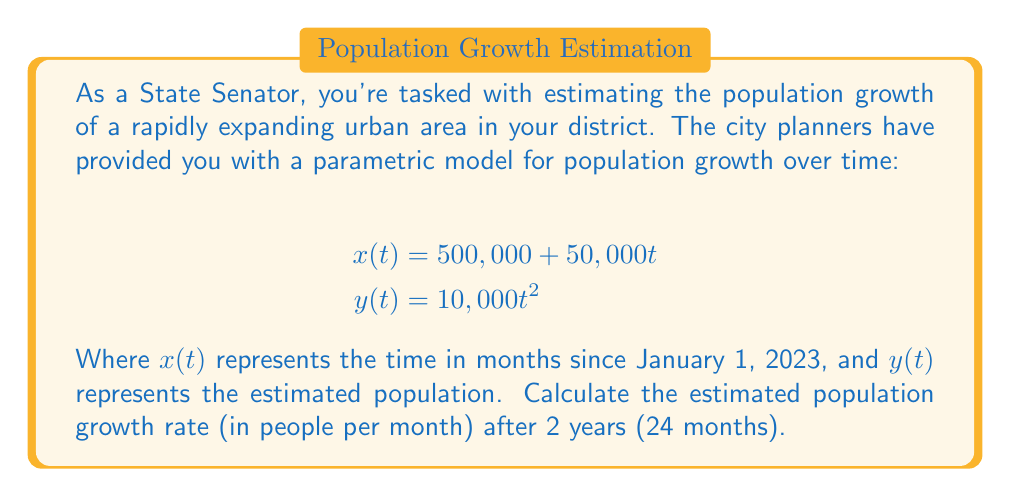Provide a solution to this math problem. To solve this problem, we need to follow these steps:

1) First, we need to understand what the parametric equations represent:
   $x(t)$ gives us the time in months
   $y(t)$ gives us the population at that time

2) We're asked about the growth rate after 2 years, which is 24 months. So we need to find the derivative of $y$ with respect to $x$ at $t = 24$.

3) To do this, we'll use the chain rule:

   $$\frac{dy}{dx} = \frac{dy/dt}{dx/dt}$$

4) Let's find $dy/dt$ and $dx/dt$:

   $$\frac{dy}{dt} = 20,000t$$
   $$\frac{dx}{dt} = 50,000$$

5) Now we can substitute these into our equation:

   $$\frac{dy}{dx} = \frac{20,000t}{50,000} = \frac{2t}{5}$$

6) We want to know this value at $t = 24$:

   $$\frac{dy}{dx}\bigg|_{t=24} = \frac{2(24)}{5} = \frac{48}{5} = 9.6$$

7) This means that after 2 years, the population is growing at a rate of 9.6 people per month.

8) However, as politicians often prefer whole numbers for ease of communication, we can round this to 10 people per month.
Answer: The estimated population growth rate after 2 years is approximately 10 people per month. 